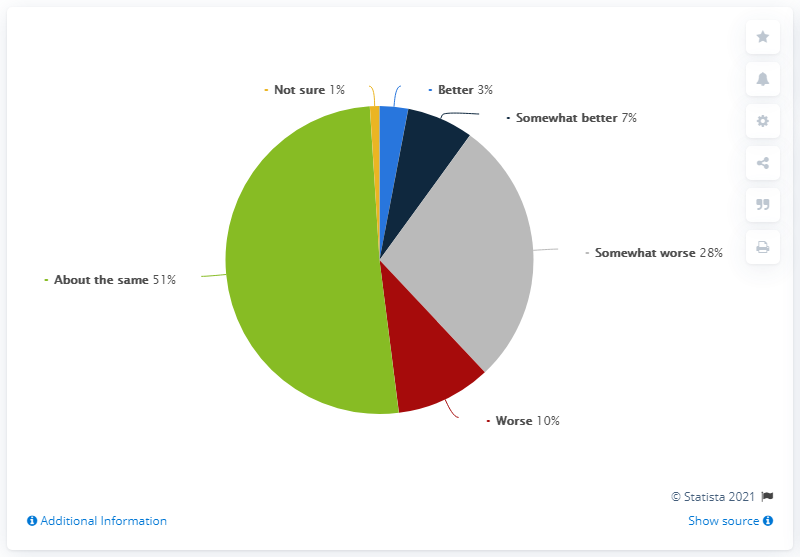Identify some key points in this picture. The color yellow suggests uncertainty and confusion since it is not clear what it represents. The number of times 'somewhat worse' is preferred to 'somewhat better' is 4. 